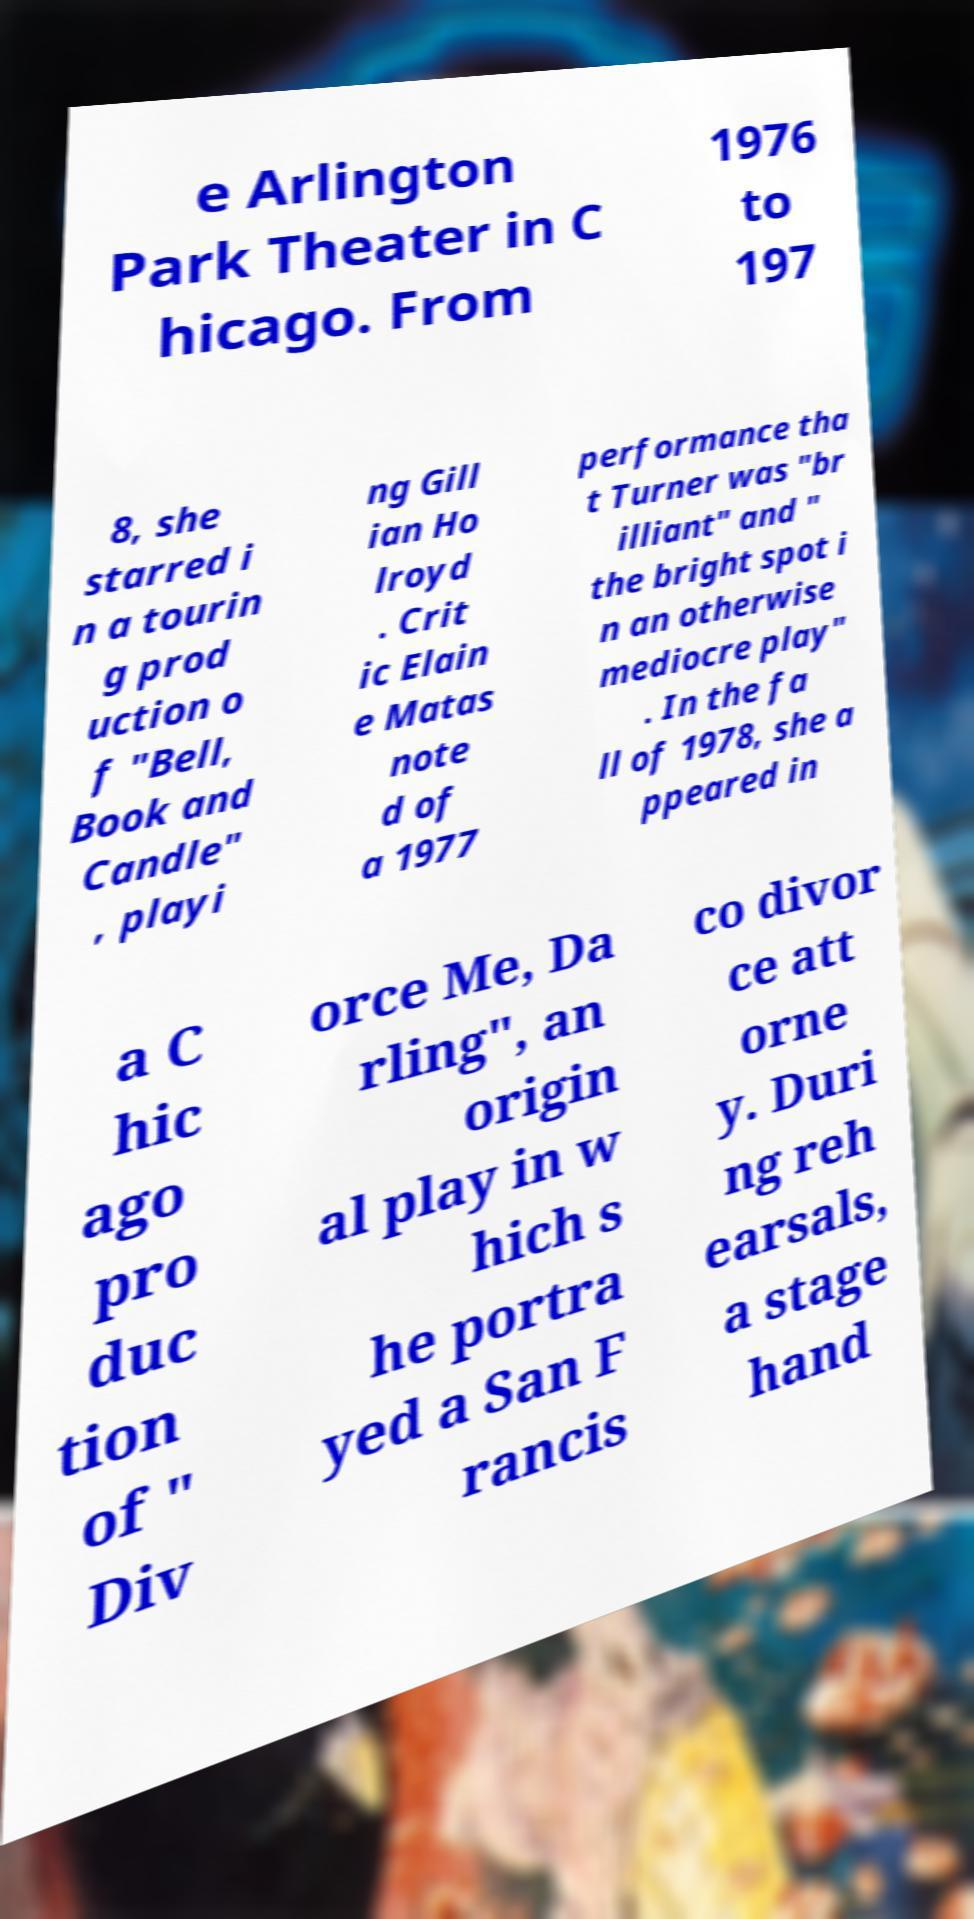Please identify and transcribe the text found in this image. e Arlington Park Theater in C hicago. From 1976 to 197 8, she starred i n a tourin g prod uction o f "Bell, Book and Candle" , playi ng Gill ian Ho lroyd . Crit ic Elain e Matas note d of a 1977 performance tha t Turner was "br illiant" and " the bright spot i n an otherwise mediocre play" . In the fa ll of 1978, she a ppeared in a C hic ago pro duc tion of " Div orce Me, Da rling", an origin al play in w hich s he portra yed a San F rancis co divor ce att orne y. Duri ng reh earsals, a stage hand 